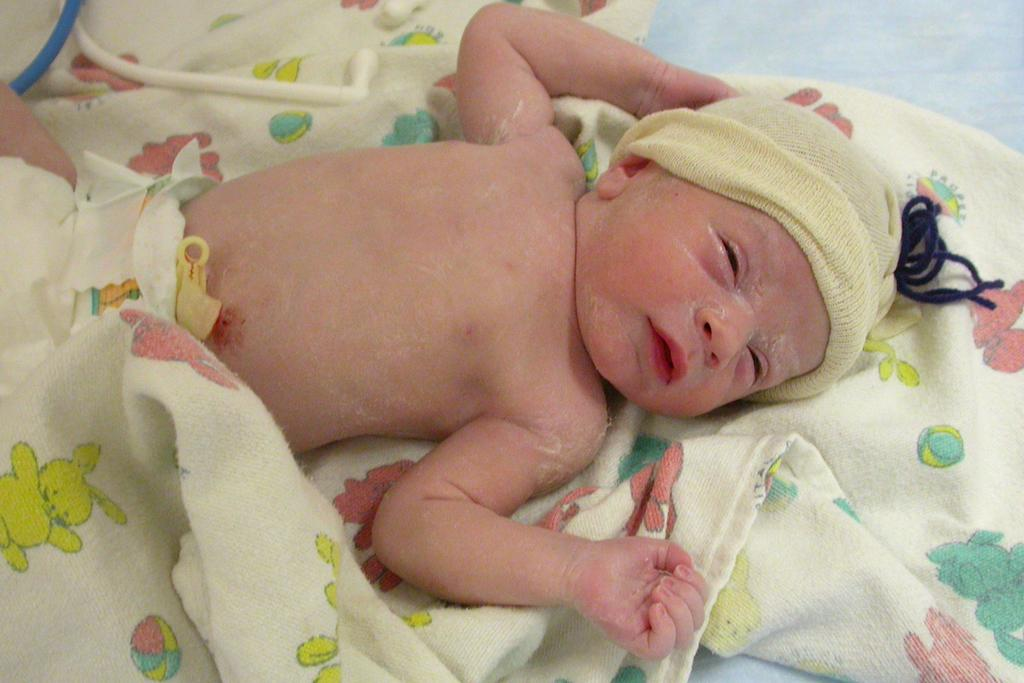What is the main subject of the picture? The main subject of the picture is a newborn infant baby. What is the baby wearing on its head? The baby is wearing a cap. What else can be seen in the picture besides the baby? There is a blanket and pipes visible in the picture. What type of lunch is the baby eating in the picture? There is no indication in the image that the baby is eating any lunch, so it cannot be determined from the picture. 